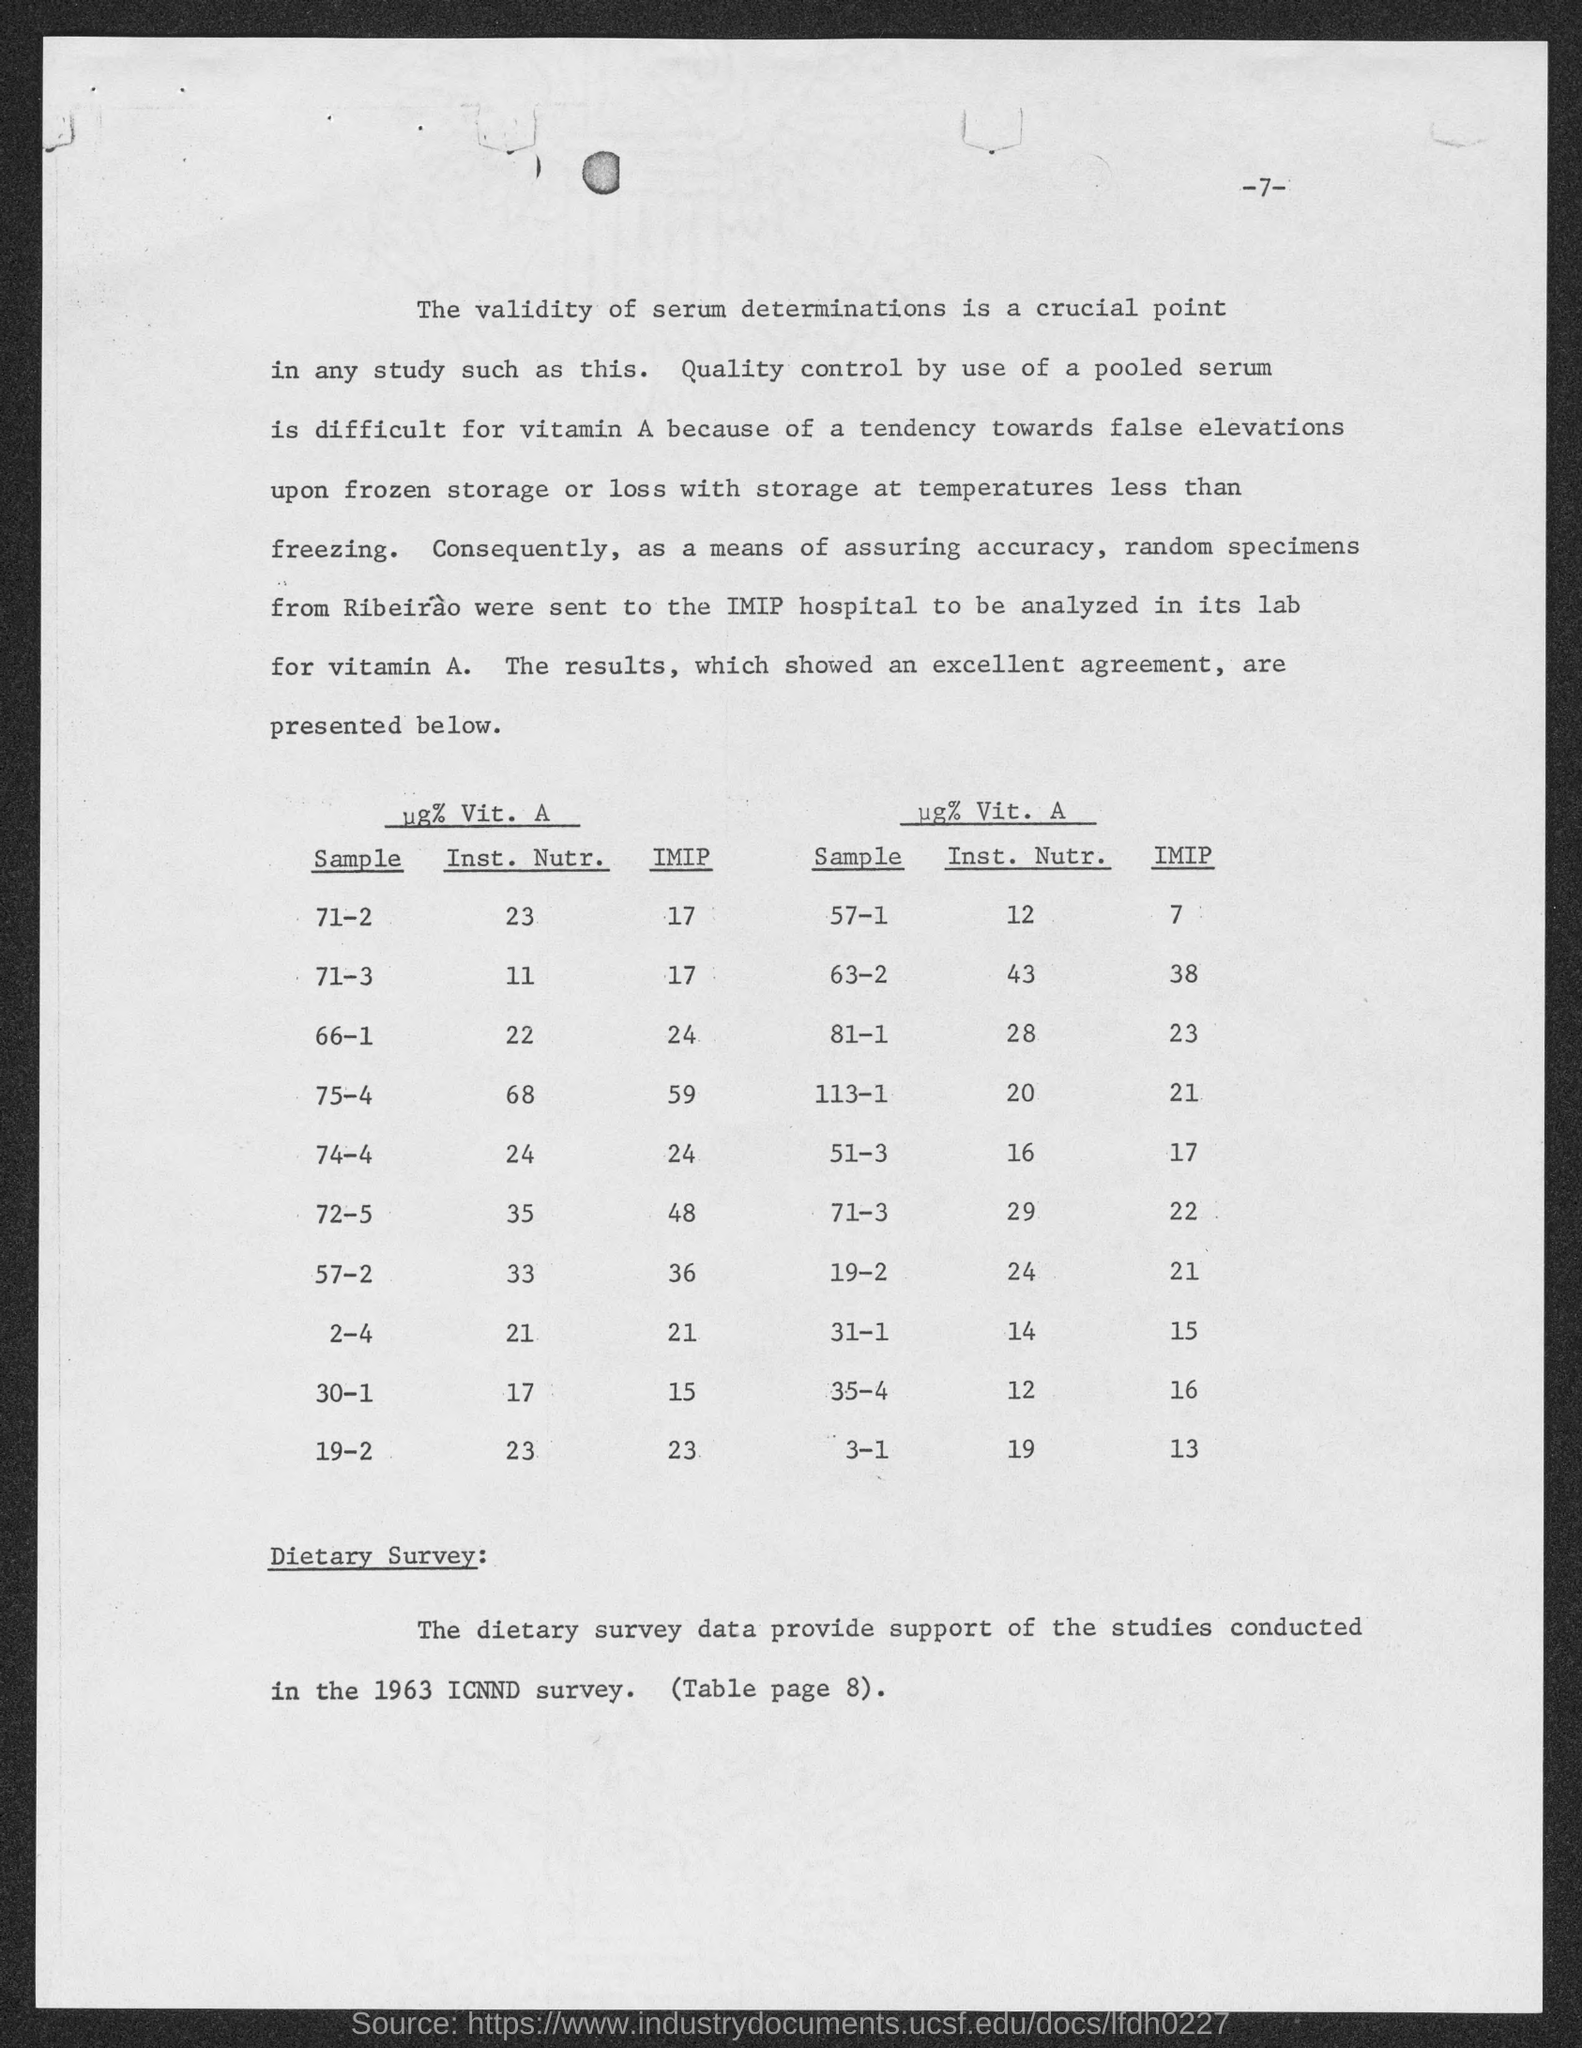Outline some significant characteristics in this image. The IMIP, or Individual Maximum Incremental Practicality, for Sample 71-3 is 17. The IMIP (Impact Mechanics of Impact) for Sample 57-2 is 36. The IMIP (importance measure) for Sample 57-1 is 7.. The IMIP (In-Month Moving Average Intercept) for Sample 74-4 is 24. The IMIP for Sample 66-1 is 24. 